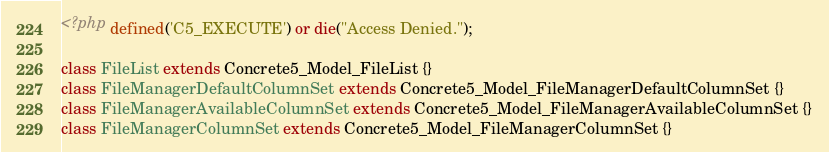Convert code to text. <code><loc_0><loc_0><loc_500><loc_500><_PHP_><?php defined('C5_EXECUTE') or die("Access Denied.");

class FileList extends Concrete5_Model_FileList {}
class FileManagerDefaultColumnSet extends Concrete5_Model_FileManagerDefaultColumnSet {}
class FileManagerAvailableColumnSet extends Concrete5_Model_FileManagerAvailableColumnSet {}
class FileManagerColumnSet extends Concrete5_Model_FileManagerColumnSet {}</code> 